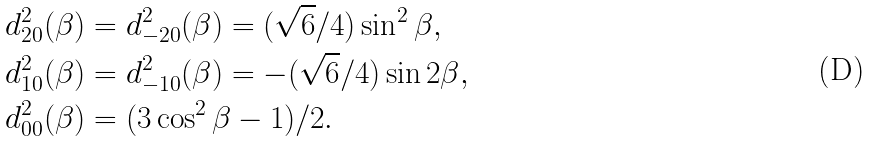<formula> <loc_0><loc_0><loc_500><loc_500>d _ { 2 0 } ^ { 2 } ( \beta ) & = d _ { - 2 0 } ^ { 2 } ( \beta ) = ( \sqrt { 6 } / 4 ) \sin ^ { 2 } \beta , \\ d _ { 1 0 } ^ { 2 } ( \beta ) & = d _ { - 1 0 } ^ { 2 } ( \beta ) = - ( \sqrt { 6 } / 4 ) \sin 2 \beta , \\ d _ { 0 0 } ^ { 2 } ( \beta ) & = ( 3 \cos ^ { 2 } \beta - 1 ) / 2 .</formula> 